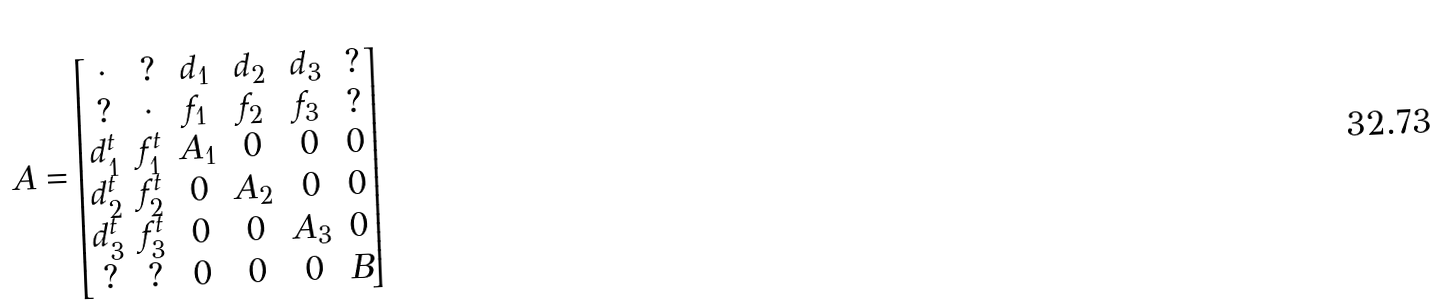<formula> <loc_0><loc_0><loc_500><loc_500>A = \begin{bmatrix} \cdot & ? & d _ { 1 } & d _ { 2 } & d _ { 3 } & ? \\ ? & \cdot & f _ { 1 } & f _ { 2 } & f _ { 3 } & ? \\ d _ { 1 } ^ { t } & f _ { 1 } ^ { t } & A _ { 1 } & 0 & 0 & 0 \\ d _ { 2 } ^ { t } & f _ { 2 } ^ { t } & 0 & A _ { 2 } & 0 & 0 \\ d _ { 3 } ^ { t } & f _ { 3 } ^ { t } & 0 & 0 & A _ { 3 } & 0 \\ ? & ? & 0 & 0 & 0 & B \end{bmatrix}</formula> 